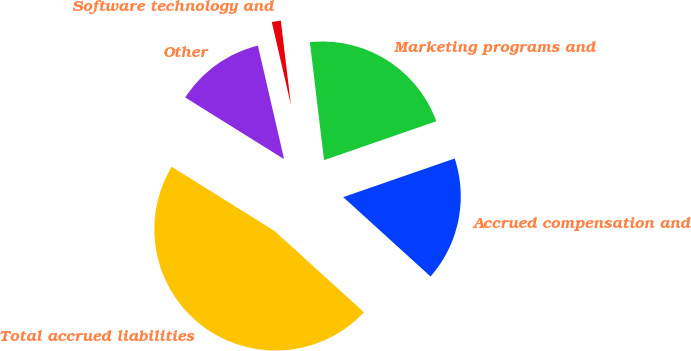Convert chart. <chart><loc_0><loc_0><loc_500><loc_500><pie_chart><fcel>Accrued compensation and<fcel>Marketing programs and<fcel>Software technology and<fcel>Other<fcel>Total accrued liabilities<nl><fcel>17.05%<fcel>21.59%<fcel>1.71%<fcel>12.51%<fcel>47.13%<nl></chart> 